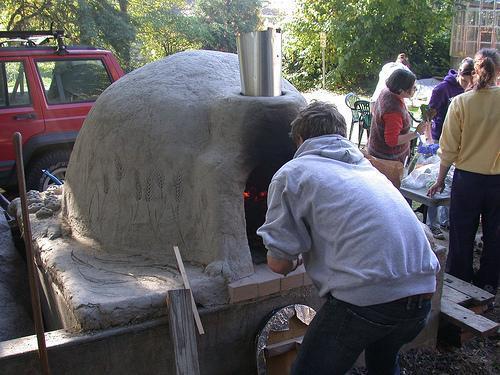How many people in photo?
Give a very brief answer. 5. 